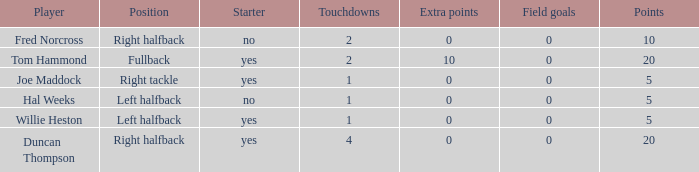How many touchdowns are there when there were 0 extra points and Hal Weeks had left halfback? 1.0. 